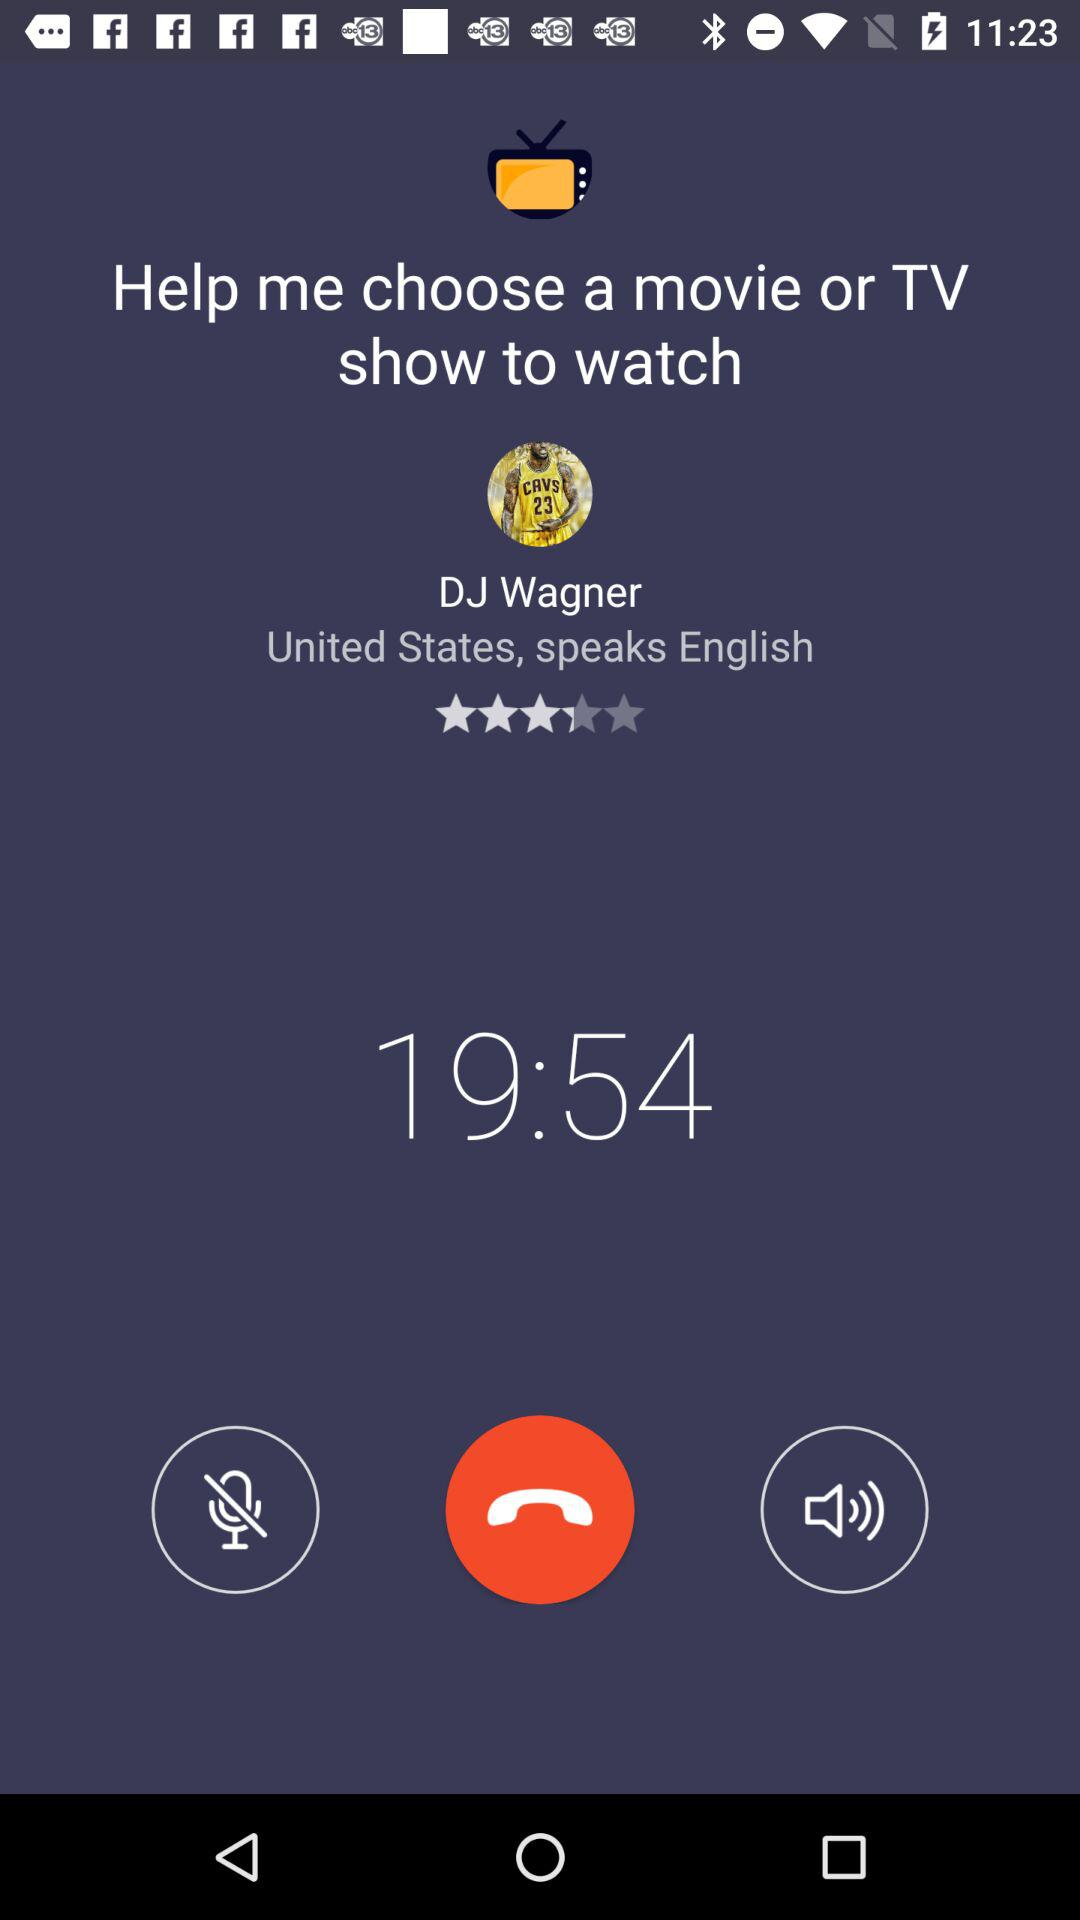Which language is spoken? The spoken language is English. 